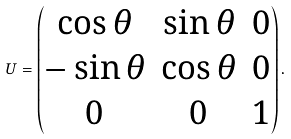Convert formula to latex. <formula><loc_0><loc_0><loc_500><loc_500>U = \begin{pmatrix} \cos \theta & \sin \theta & 0 \\ - \sin \theta & \cos \theta & 0 \\ 0 & 0 & 1 \end{pmatrix} .</formula> 